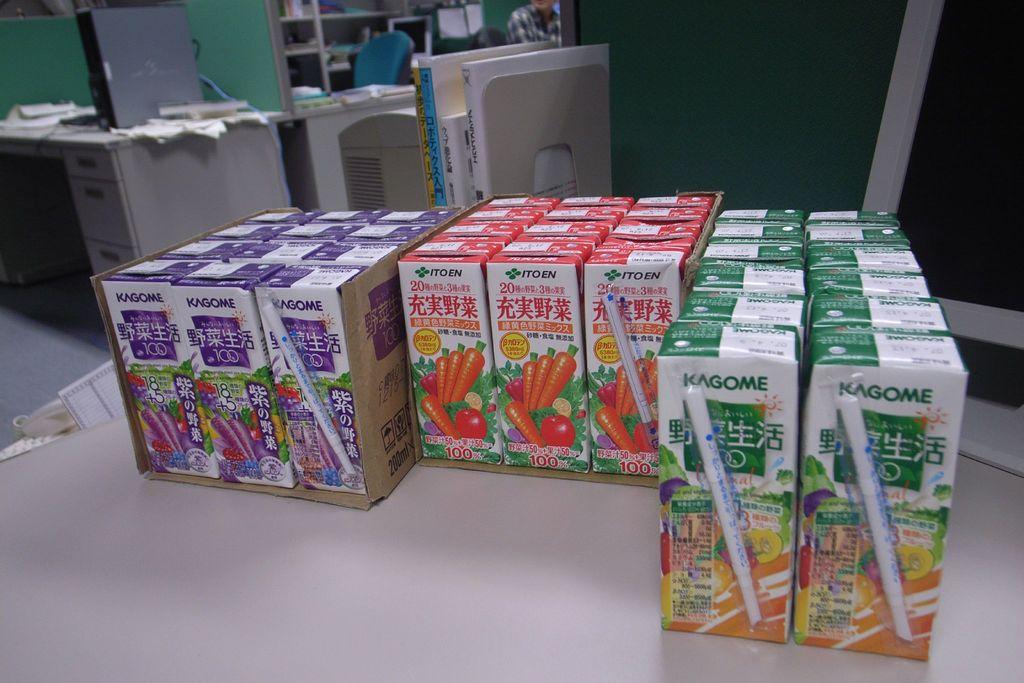What number is written on the front of each box?
Offer a very short reply. 100. What is the brand of juice box?
Provide a short and direct response. Kagome. 